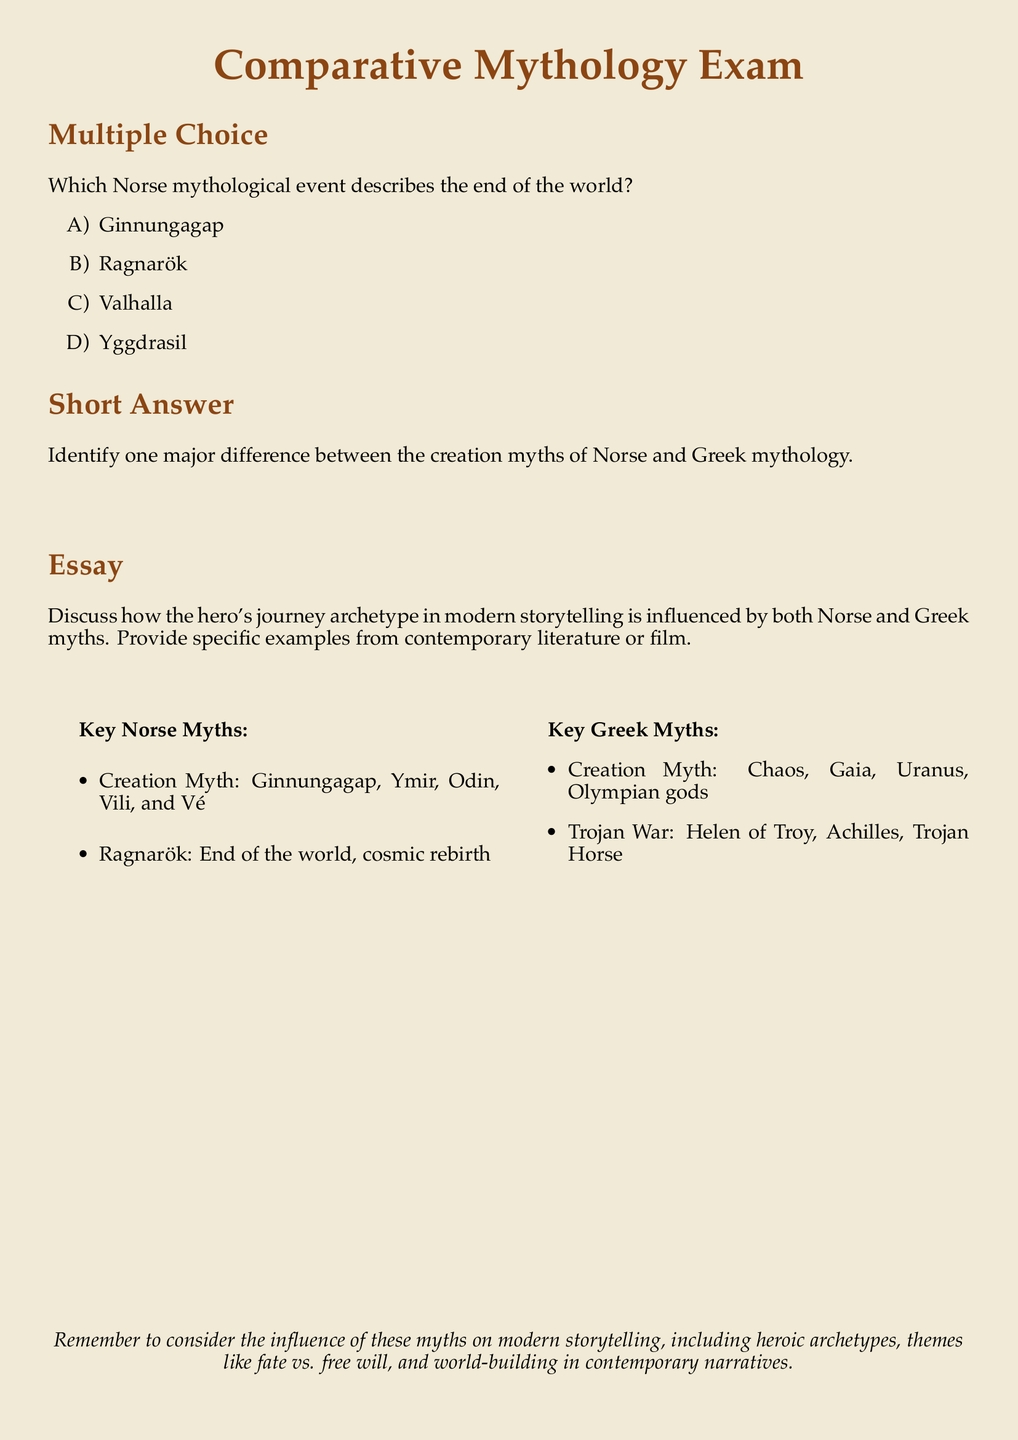What is the title of the exam? The title is prominently displayed at the top of the document and is "Comparative Mythology Exam."
Answer: Comparative Mythology Exam Which Norse mythological event describes the end of the world? This is a multiple-choice question presented along with options in the document. The correct answer is given as Ragnarök.
Answer: Ragnarök Name one major difference in creation myths mentioned in the document. The short answer section asks for a major difference but doesn't specify; however, readers should infer differences based on the content.
Answer: Chaos vs. Ginnungagap What two major figures are mentioned in the Norse creation myth? The key Norse myths section lists Ymir and Odin among other figures.
Answer: Ymir, Odin According to the document, what is the main theme that modern storytelling should consider from these myths? The document highlights several themes, prompting consideration of "fate vs. free will" among other things.
Answer: Fate vs. free will Which document section contains the multiple-choice question? The section titles in the document indicate where the question types are listed; the multiple-choice section is clearly labeled.
Answer: Multiple Choice What is one key Greek myth mentioned relating to the Trojan War? This information is found in the key Greek myths section. A specific event linked to the Trojan War is highlighted.
Answer: Trojan Horse What archetype does the essay prompt encourage discussion of? The essay section directly refers to "the hero's journey archetype" from storytelling influenced by myths.
Answer: Hero's journey archetype 